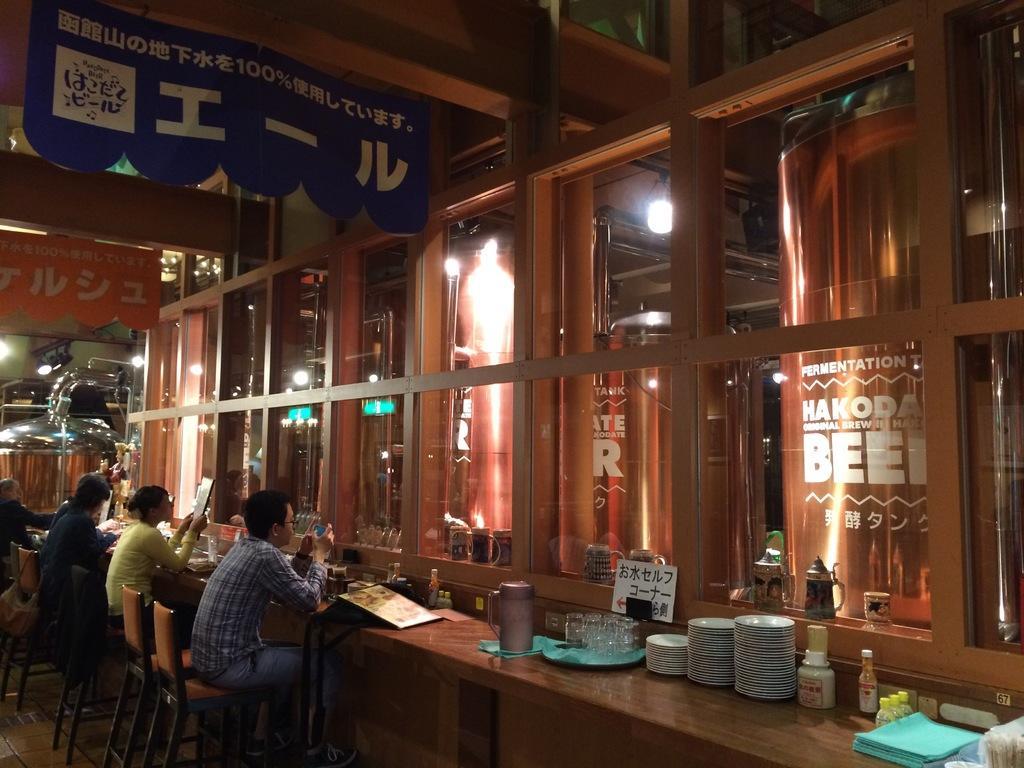Could you give a brief overview of what you see in this image? There are few people sitting on the chair at the table. On the table we can see plates,bottles. jugs,gasses and where there is a glass door and a cloth on the table. 